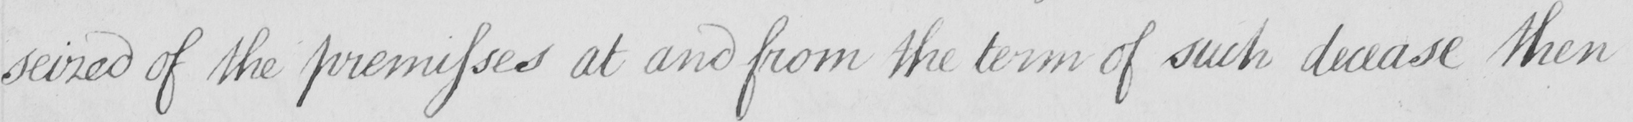What text is written in this handwritten line? seized of the premises at and from the term of such decease then 